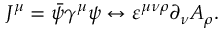<formula> <loc_0><loc_0><loc_500><loc_500>J ^ { \mu } = \bar { \psi } \gamma ^ { \mu } \psi \leftrightarrow \varepsilon ^ { \mu \nu \rho } \partial _ { \nu } A _ { \rho } .</formula> 